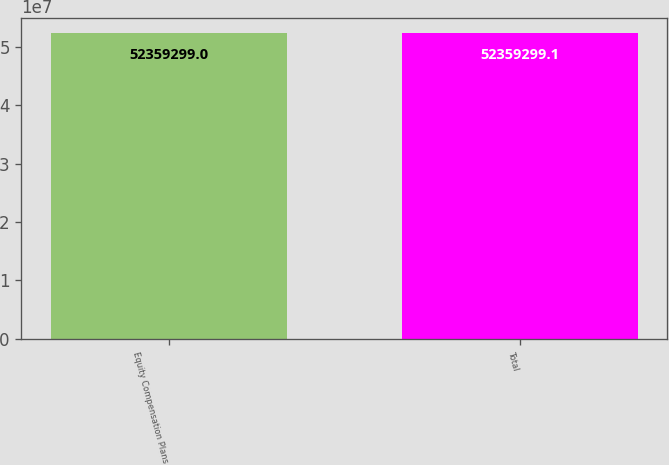Convert chart. <chart><loc_0><loc_0><loc_500><loc_500><bar_chart><fcel>Equity Compensation Plans<fcel>Total<nl><fcel>5.23593e+07<fcel>5.23593e+07<nl></chart> 